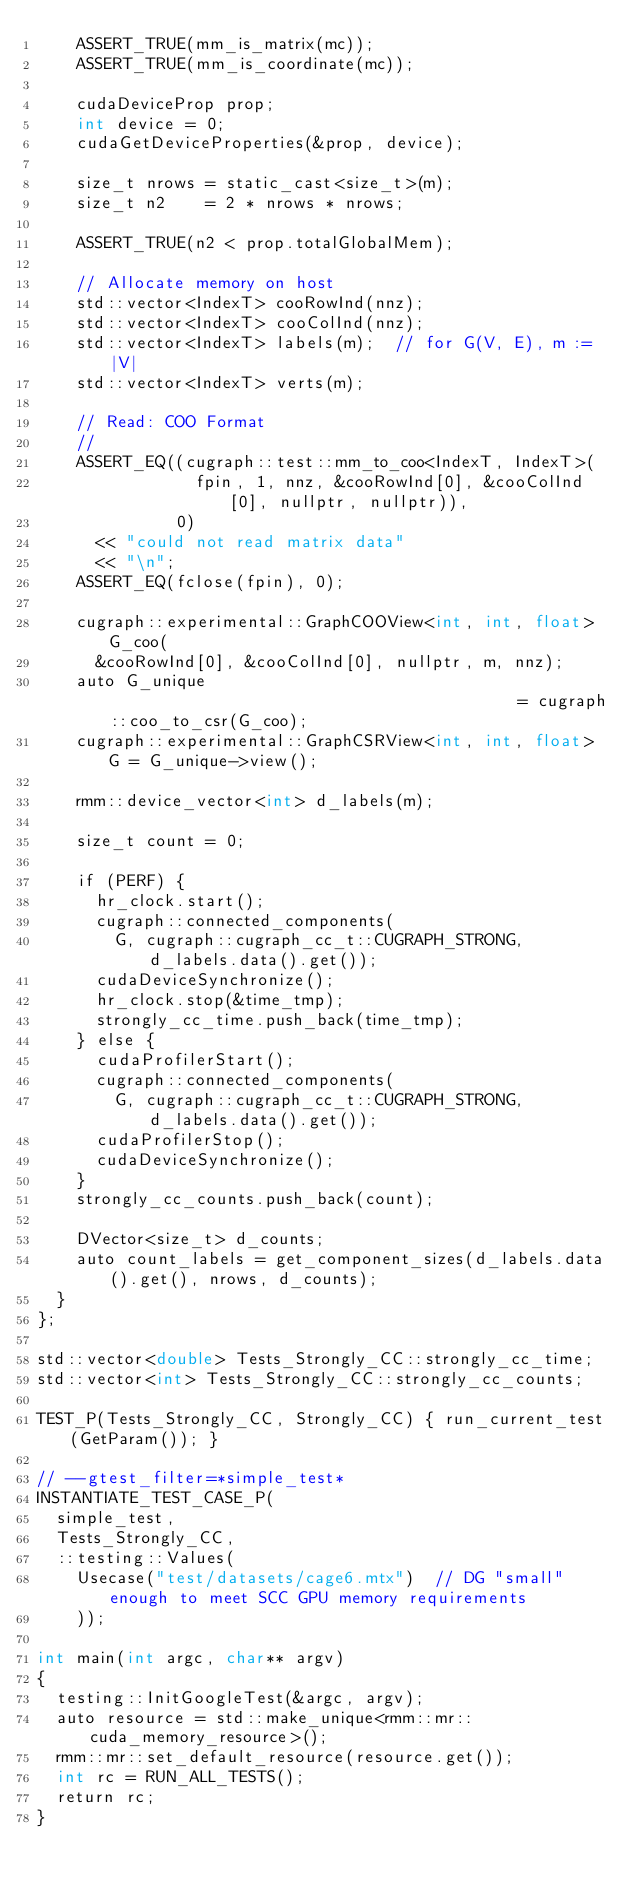<code> <loc_0><loc_0><loc_500><loc_500><_Cuda_>    ASSERT_TRUE(mm_is_matrix(mc));
    ASSERT_TRUE(mm_is_coordinate(mc));

    cudaDeviceProp prop;
    int device = 0;
    cudaGetDeviceProperties(&prop, device);

    size_t nrows = static_cast<size_t>(m);
    size_t n2    = 2 * nrows * nrows;

    ASSERT_TRUE(n2 < prop.totalGlobalMem);

    // Allocate memory on host
    std::vector<IndexT> cooRowInd(nnz);
    std::vector<IndexT> cooColInd(nnz);
    std::vector<IndexT> labels(m);  // for G(V, E), m := |V|
    std::vector<IndexT> verts(m);

    // Read: COO Format
    //
    ASSERT_EQ((cugraph::test::mm_to_coo<IndexT, IndexT>(
                fpin, 1, nnz, &cooRowInd[0], &cooColInd[0], nullptr, nullptr)),
              0)
      << "could not read matrix data"
      << "\n";
    ASSERT_EQ(fclose(fpin), 0);

    cugraph::experimental::GraphCOOView<int, int, float> G_coo(
      &cooRowInd[0], &cooColInd[0], nullptr, m, nnz);
    auto G_unique                                          = cugraph::coo_to_csr(G_coo);
    cugraph::experimental::GraphCSRView<int, int, float> G = G_unique->view();

    rmm::device_vector<int> d_labels(m);

    size_t count = 0;

    if (PERF) {
      hr_clock.start();
      cugraph::connected_components(
        G, cugraph::cugraph_cc_t::CUGRAPH_STRONG, d_labels.data().get());
      cudaDeviceSynchronize();
      hr_clock.stop(&time_tmp);
      strongly_cc_time.push_back(time_tmp);
    } else {
      cudaProfilerStart();
      cugraph::connected_components(
        G, cugraph::cugraph_cc_t::CUGRAPH_STRONG, d_labels.data().get());
      cudaProfilerStop();
      cudaDeviceSynchronize();
    }
    strongly_cc_counts.push_back(count);

    DVector<size_t> d_counts;
    auto count_labels = get_component_sizes(d_labels.data().get(), nrows, d_counts);
  }
};

std::vector<double> Tests_Strongly_CC::strongly_cc_time;
std::vector<int> Tests_Strongly_CC::strongly_cc_counts;

TEST_P(Tests_Strongly_CC, Strongly_CC) { run_current_test(GetParam()); }

// --gtest_filter=*simple_test*
INSTANTIATE_TEST_CASE_P(
  simple_test,
  Tests_Strongly_CC,
  ::testing::Values(
    Usecase("test/datasets/cage6.mtx")  // DG "small" enough to meet SCC GPU memory requirements
    ));

int main(int argc, char** argv)
{
  testing::InitGoogleTest(&argc, argv);
  auto resource = std::make_unique<rmm::mr::cuda_memory_resource>();
  rmm::mr::set_default_resource(resource.get());
  int rc = RUN_ALL_TESTS();
  return rc;
}
</code> 